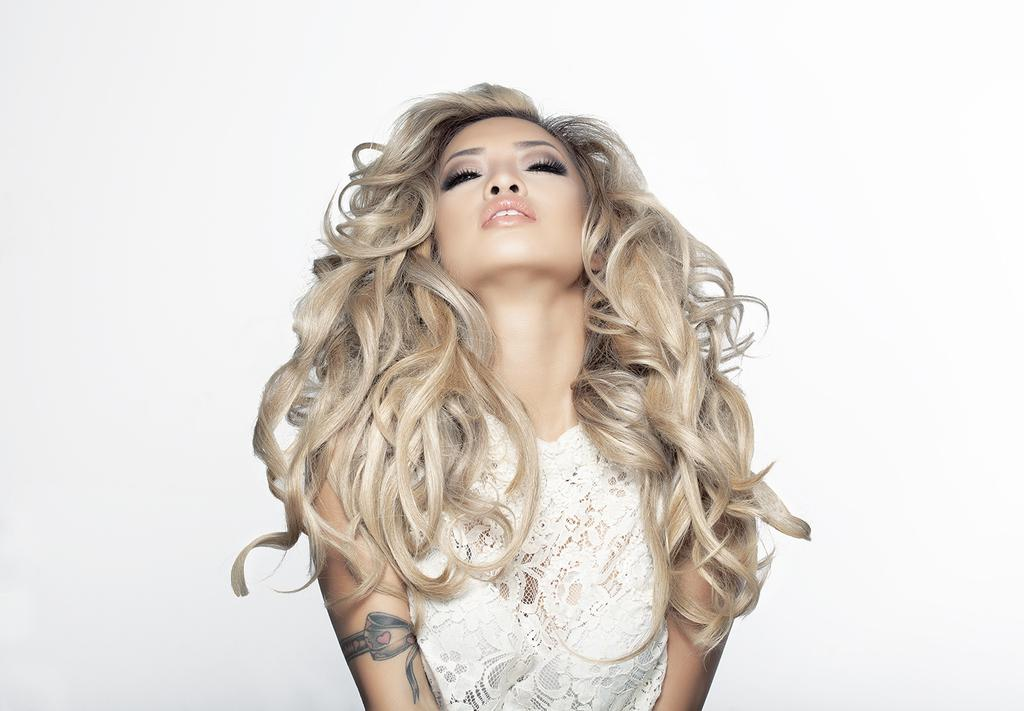What is the main subject of the picture? The main subject of the picture is a woman. What is the woman doing in the picture? The woman is posing for a photo. Can you describe the woman's hair in the picture? The woman has curly hair. What is the woman wearing in the picture? The woman is wearing a white dress. What is the color of the background in the picture? The background of the image is in white color. What type of stew is being prepared in the background of the image? There is no stew present in the image; it features a woman posing for a photo with a white background. Can you tell me the color of the orange in the image? There is no orange present in the image. 